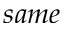<formula> <loc_0><loc_0><loc_500><loc_500>s a m e</formula> 